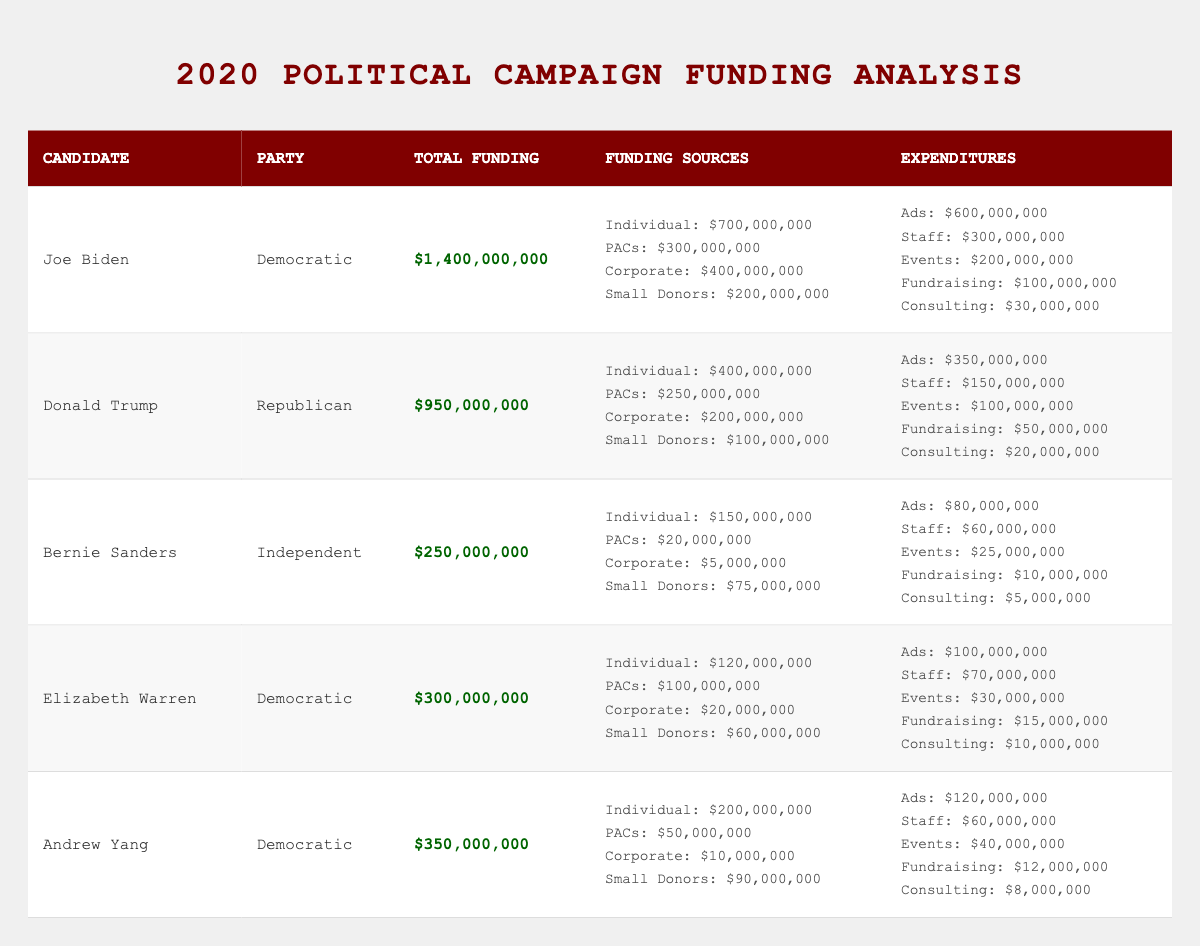What is the total funding for Joe Biden's campaign? Joe Biden's total funding is directly listed in the table as $1,400,000,000.
Answer: $1,400,000,000 Which party does Donald Trump belong to? The party affiliation for Donald Trump is explicitly stated in the table as Republican.
Answer: Republican How much did Bernie Sanders receive from Individual Contributions? Bernie Sanders' Individual Contributions is noted in the Sources section of the table as $150,000,000.
Answer: $150,000,000 What is the total expenditure for Elizabeth Warren's campaign? Elizabeth Warren's total expenditures can be found in the Expenditures section of the table, which sums to $325,000,000.
Answer: $325,000,000 Who has the highest Ad Spend among the candidates? By comparing the Ad Spend amounts listed in the Expenditures section, Joe Biden has the highest at $600,000,000.
Answer: Joe Biden What is the difference in Total Funding between Joe Biden and Donald Trump? Joe Biden's total funding is $1,400,000,000 and Donald Trump's is $950,000,000. The difference is $1,400,000,000 - $950,000,000 = $450,000,000.
Answer: $450,000,000 Which candidate had the lowest Corporate Donations? In the Sources section, Bernie Sanders has the lowest Corporate Donations listed as $5,000,000.
Answer: Bernie Sanders What percentage of Andrew Yang's funding came from Small Donor Contributions? Andrew Yang's Small Donor Contributions are $90,000,000 out of a total funding of $350,000,000. The percentage is calculated as ($90,000,000 / $350,000,000) * 100 = 25.71%.
Answer: 25.71% Is the total funding for Elizabeth Warren higher than that for Bernie Sanders? Comparing the total funding, Elizabeth Warren has $300,000,000, and Bernie Sanders has $250,000,000. Since $300,000,000 is greater, the statement is true.
Answer: Yes If you combine the Ad Spend of Joe Biden and Donald Trump, how much is it? Joe Biden's Ad Spend is $600,000,000 and Donald Trump's is $350,000,000. The combined Ad Spend is $600,000,000 + $350,000,000 = $950,000,000.
Answer: $950,000,000 What is the total of Small Donor Contributions for all Democratic candidates? The Small Donor Contributions for Joe Biden is $200,000,000, for Elizabeth Warren is $60,000,000, and for Andrew Yang is $90,000,000. The total is $200,000,000 + $60,000,000 + $90,000,000 = $350,000,000.
Answer: $350,000,000 Which candidate spent more on Staff Salaries, Joe Biden or Elizabeth Warren? Joe Biden spent $300,000,000 and Elizabeth Warren spent $70,000,000 on Staff Salaries as shown in the Expenditures. Hence, Joe Biden spent more.
Answer: Joe Biden What fraction of Donald Trump’s total funding came from Political Action Committees? Donald Trump's funding from Political Action Committees is $250,000,000 out of a total of $950,000,000. The fraction is $250,000,000 / $950,000,000 = 0.263, which is approximately 1/4.
Answer: 1/4 Did any candidate have more than one billion dollars in total funding? By evaluating the total funding values, only Joe Biden has more than one billion dollars; he has $1,400,000,000. Therefore, the answer is yes.
Answer: Yes 